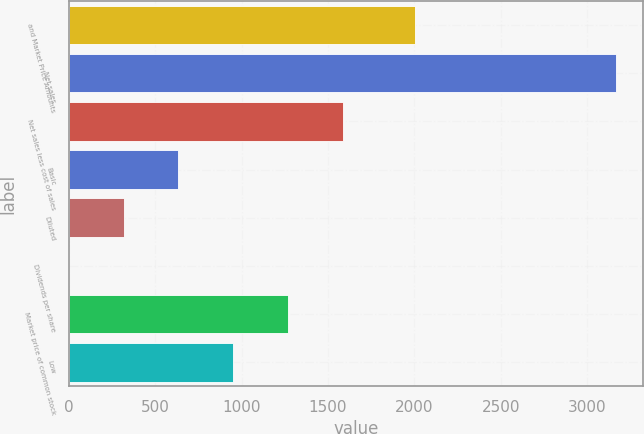Convert chart. <chart><loc_0><loc_0><loc_500><loc_500><bar_chart><fcel>and Market Price Amounts<fcel>Net sales<fcel>Net sales less cost of sales<fcel>Basic<fcel>Diluted<fcel>Dividends per share<fcel>Market price of common stock<fcel>Low<nl><fcel>2005<fcel>3168<fcel>1584.16<fcel>633.85<fcel>317.08<fcel>0.31<fcel>1267.39<fcel>950.62<nl></chart> 